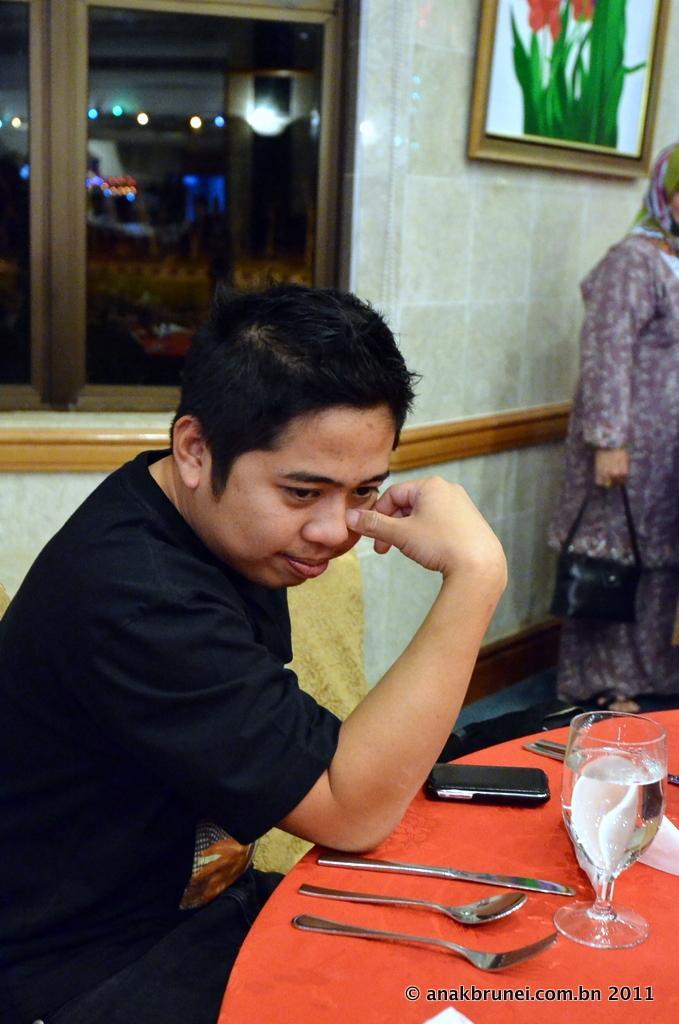Please provide a concise description of this image. In this image, I can see a man sitting. In front of the man, I can see a knife, spoon, fork, glass, mobile and few other objects on a table. On the right side of the image, I can see a person standing and holding a bag. In the background, there is a photo frame attached to the wall and I can see a glass window. In the bottom right corner of the image, I can see a watermark. 